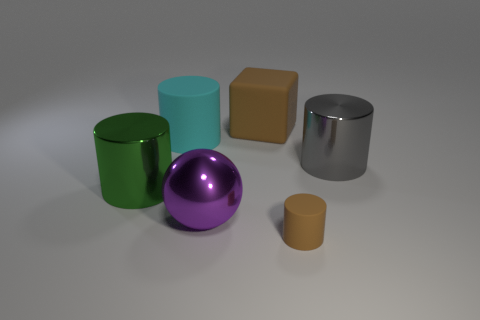Add 1 brown cylinders. How many objects exist? 7 Subtract all spheres. How many objects are left? 5 Add 1 tiny objects. How many tiny objects exist? 2 Subtract 0 purple cubes. How many objects are left? 6 Subtract all rubber cubes. Subtract all cubes. How many objects are left? 4 Add 1 small things. How many small things are left? 2 